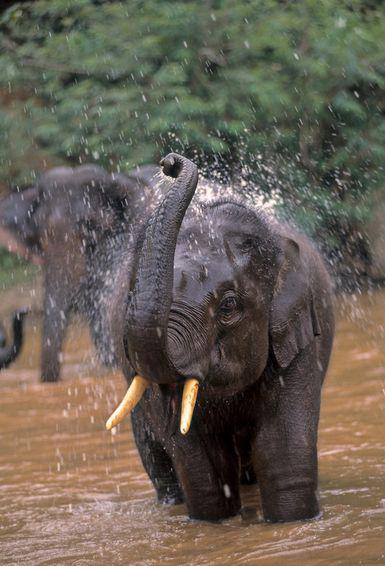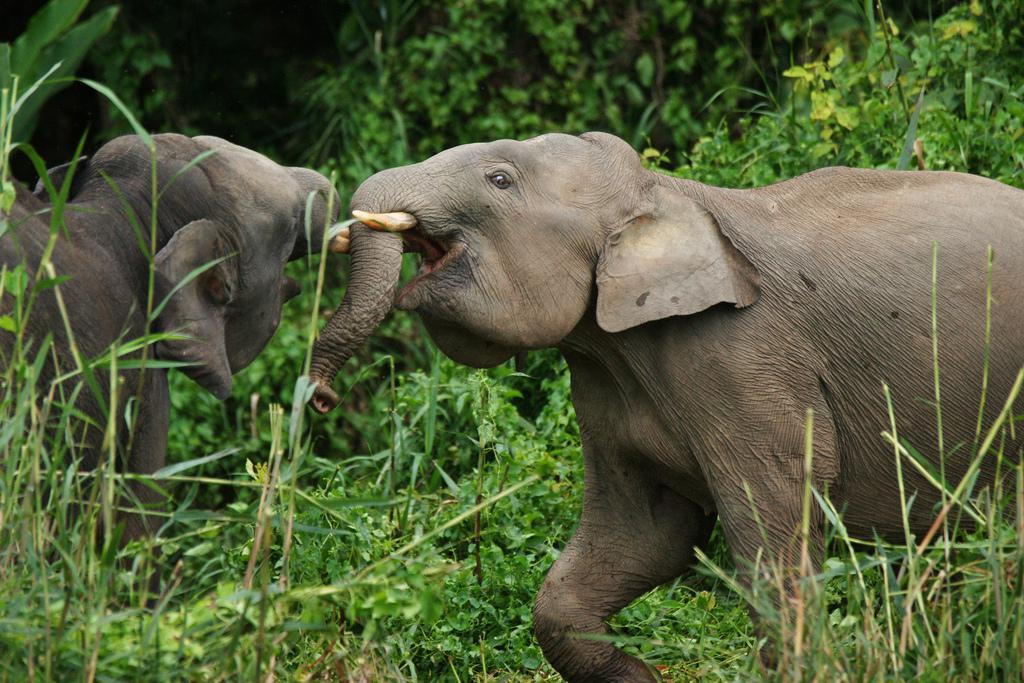The first image is the image on the left, the second image is the image on the right. Analyze the images presented: Is the assertion "One of the images contains more than three elephants." valid? Answer yes or no. No. 